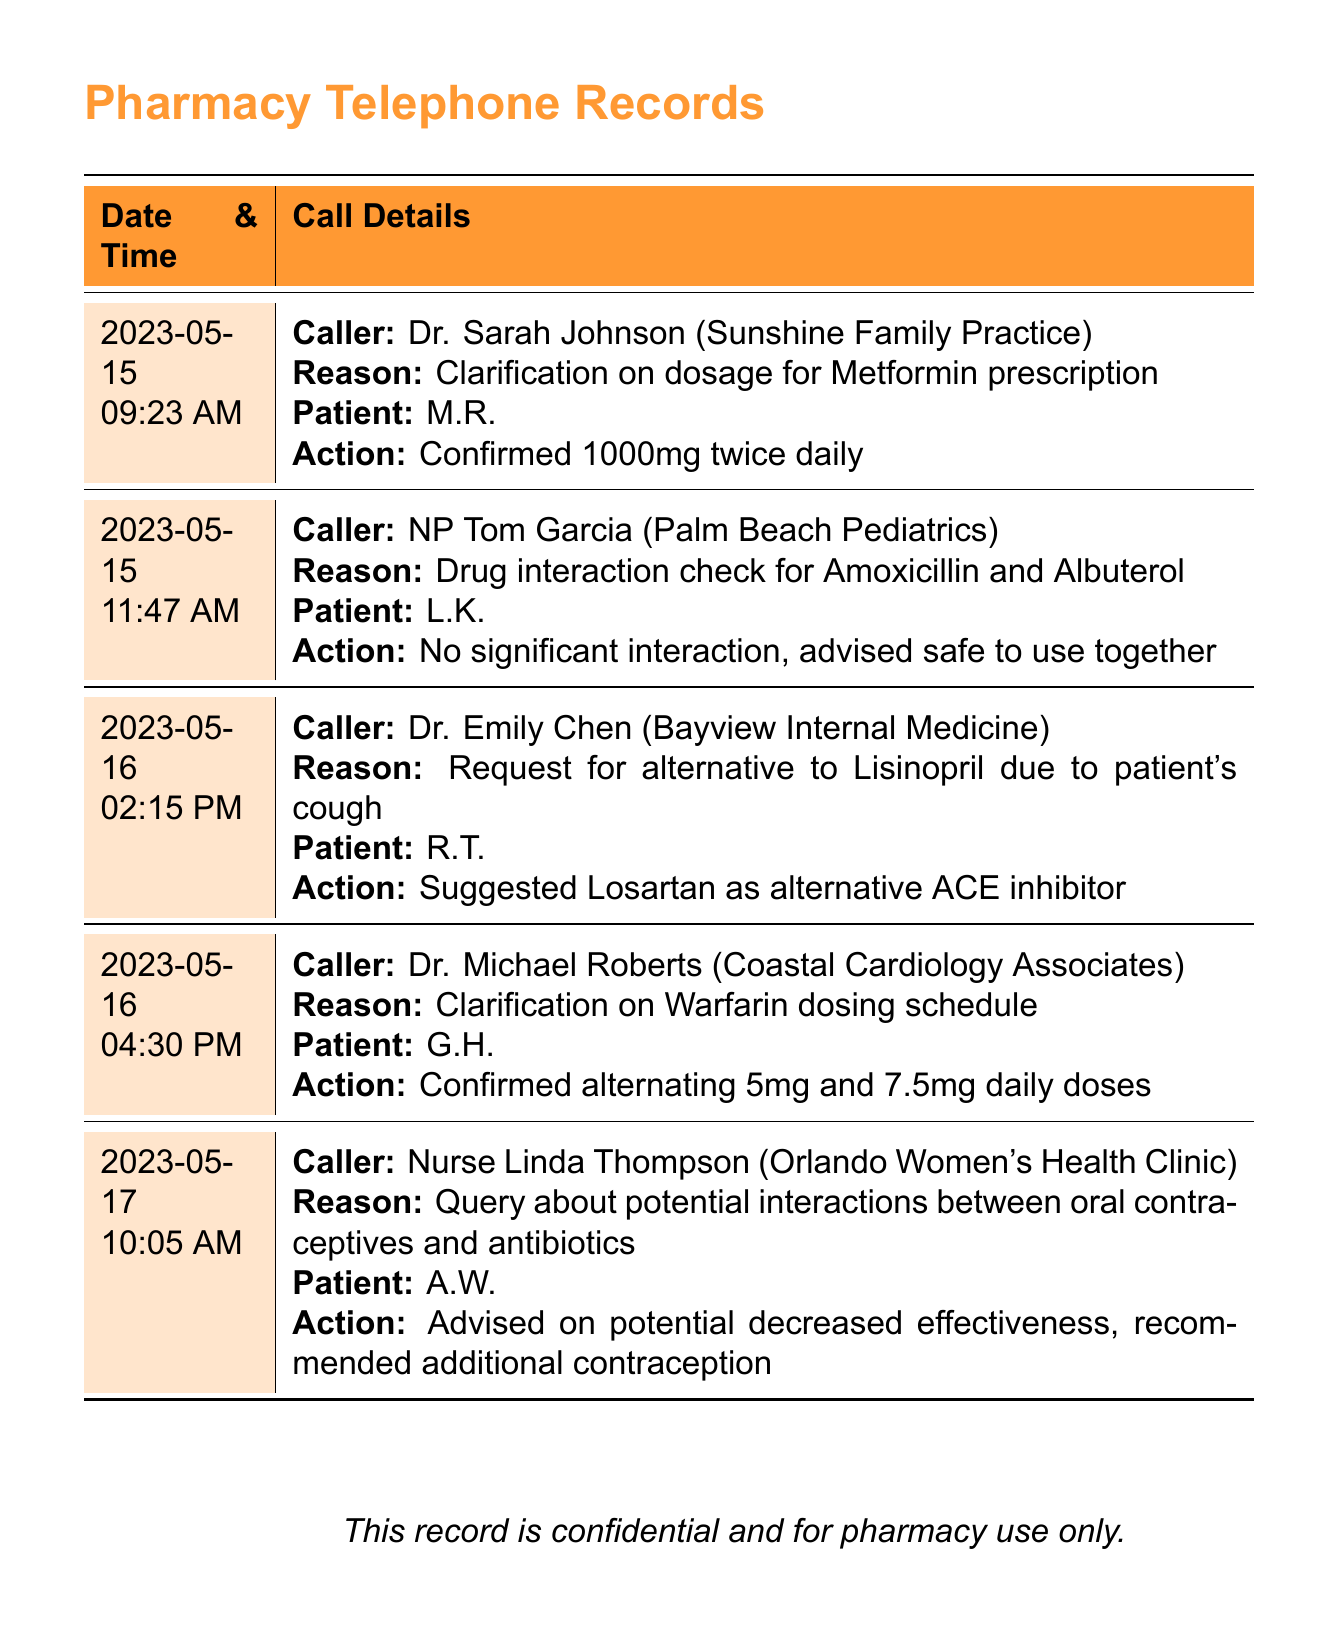What is the date of the call from Dr. Sarah Johnson? The date of the call is specified in the record for Dr. Sarah Johnson, which is 2023-05-15.
Answer: 2023-05-15 What was the reason for NP Tom Garcia's call? The reason for NP Tom Garcia's call is mentioned in the record as a drug interaction check for Amoxicillin and Albuterol.
Answer: Drug interaction check for Amoxicillin and Albuterol What alternative medication did Dr. Emily Chen suggest? The alternative medication suggested by Dr. Emily Chen is documented in the record as Losartan.
Answer: Losartan How many mg of Warfarin was confirmed for patient G.H.? The dosing schedule for Warfarin as confirmed in the record for patient G.H. is described, including 5mg and 7.5mg doses.
Answer: Alternating 5mg and 7.5mg What did Nurse Linda Thompson advise about oral contraceptives? The record contains the information that Nurse Linda Thompson advised on the potential decreased effectiveness of oral contraceptives when interacting with antibiotics.
Answer: Potential decreased effectiveness Who is the caller from Bayview Internal Medicine? The caller's name from Bayview Internal Medicine is listed in the record.
Answer: Dr. Emily Chen How many calls were logged in total? The total number of calls noted in the telephone records can be counted from the entries.
Answer: 5 calls 